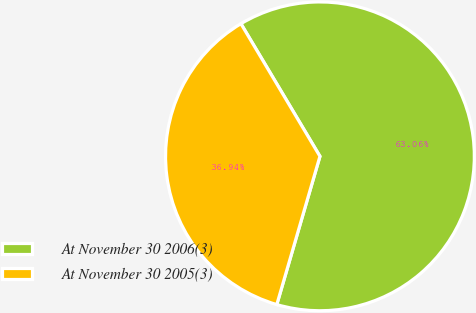<chart> <loc_0><loc_0><loc_500><loc_500><pie_chart><fcel>At November 30 2006(3)<fcel>At November 30 2005(3)<nl><fcel>63.06%<fcel>36.94%<nl></chart> 